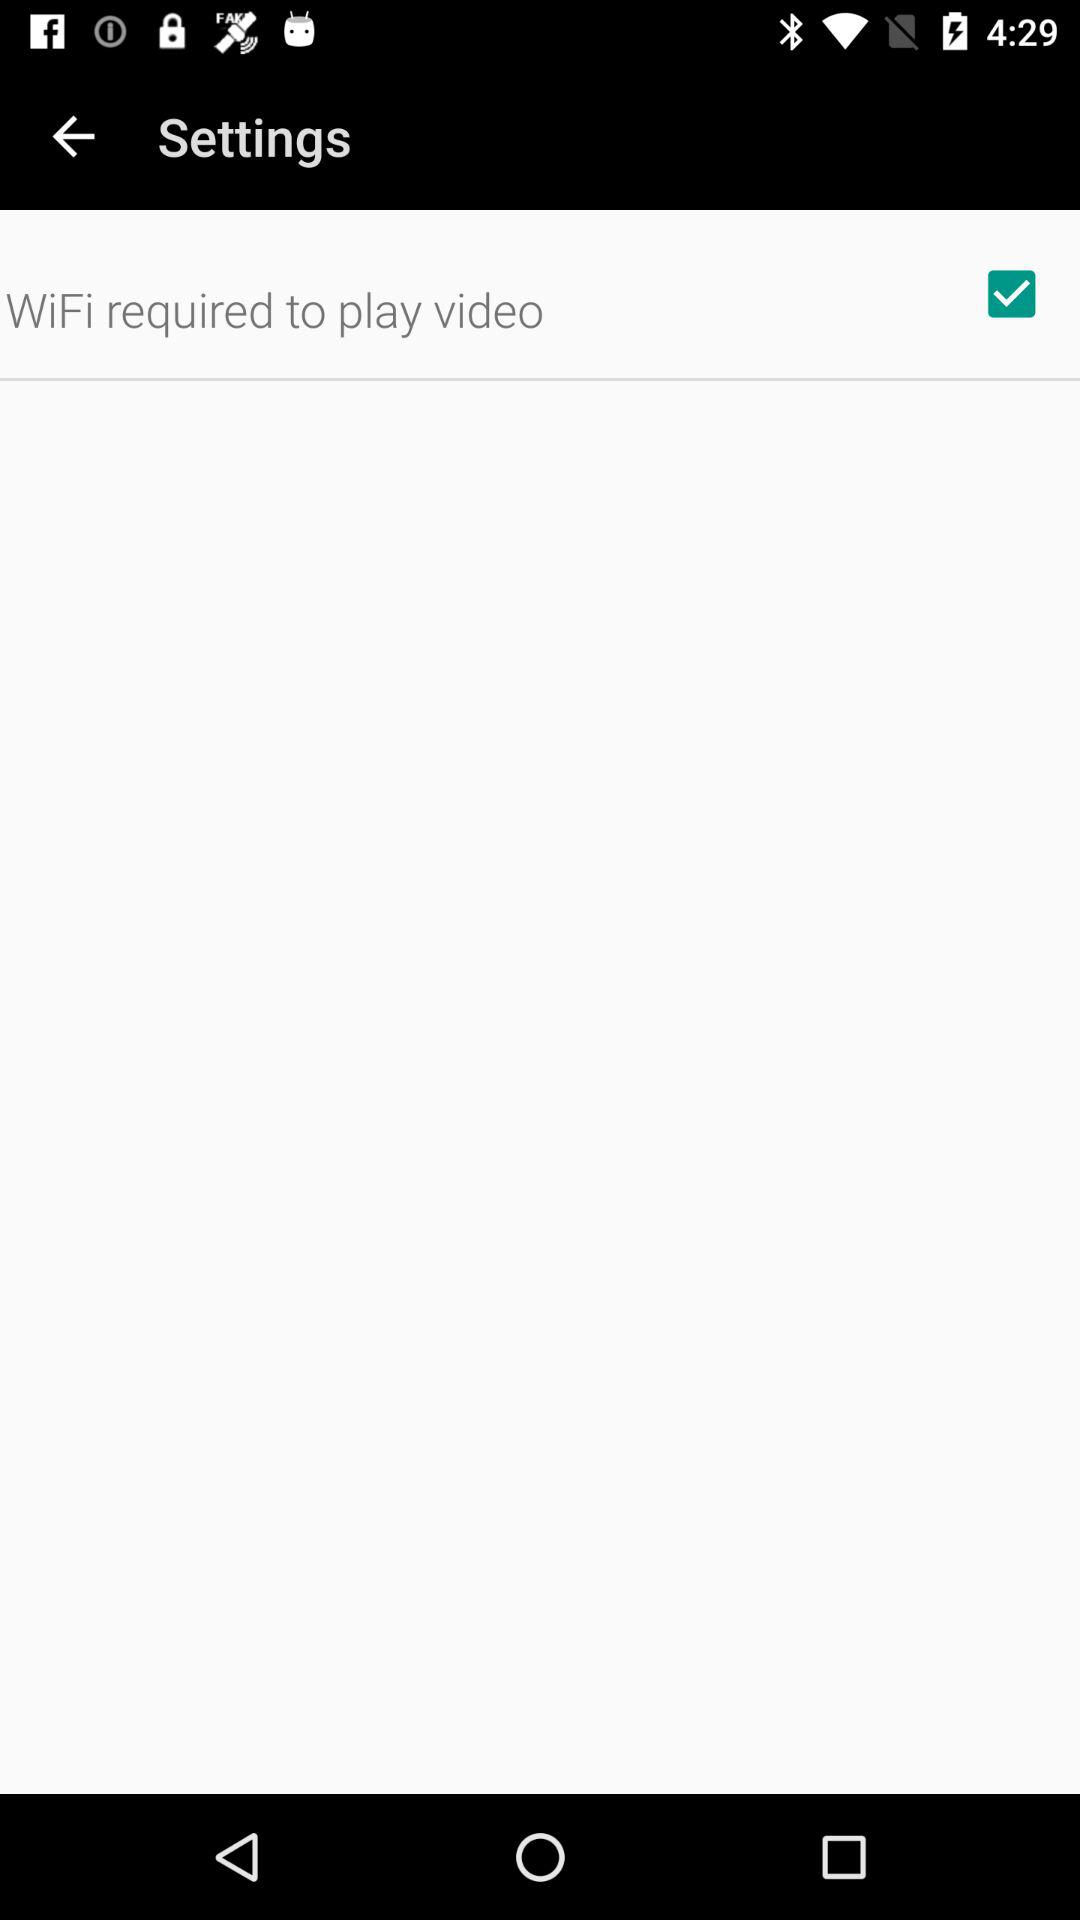What is the status of the WiFi required to play video? The status is on. 